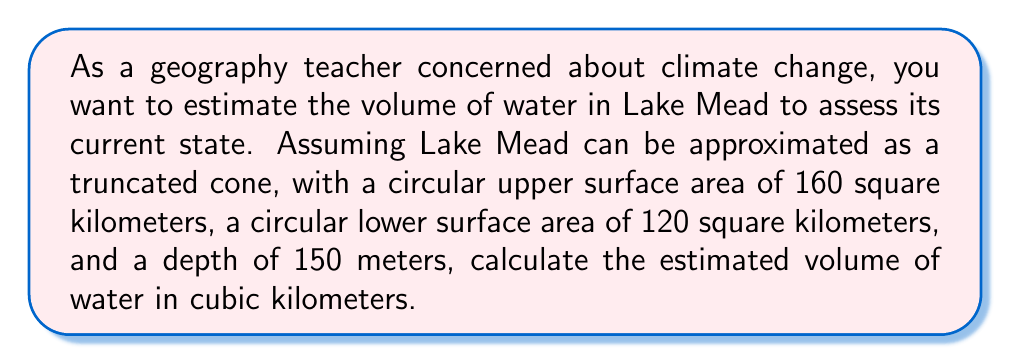What is the answer to this math problem? Let's approach this step-by-step using the formula for the volume of a truncated cone:

1) The formula for the volume of a truncated cone is:

   $$V = \frac{1}{3}\pi h(R^2 + r^2 + Rr)$$

   Where:
   $V$ = volume
   $h$ = height (depth in this case)
   $R$ = radius of the larger circular surface
   $r$ = radius of the smaller circular surface

2) We need to find $R$ and $r$ from the given surface areas:

   For the upper surface: $\pi R^2 = 160$ km²
   For the lower surface: $\pi r^2 = 120$ km²

3) Solving for $R$ and $r$:

   $$R = \sqrt{\frac{160}{\pi}} \approx 7.14 \text{ km}$$
   $$r = \sqrt{\frac{120}{\pi}} \approx 6.18 \text{ km}$$

4) Now we can substitute these values into our volume formula:

   $$V = \frac{1}{3}\pi \cdot 0.15(7.14^2 + 6.18^2 + 7.14 \cdot 6.18)$$

5) Calculating:

   $$V = \frac{1}{3}\pi \cdot 0.15(50.98 + 38.19 + 44.13)$$
   $$V = \frac{1}{3}\pi \cdot 0.15 \cdot 133.30$$
   $$V = 20.94 \text{ km}^3$$

Thus, the estimated volume of water in Lake Mead is approximately 20.94 cubic kilometers.
Answer: $20.94 \text{ km}^3$ 